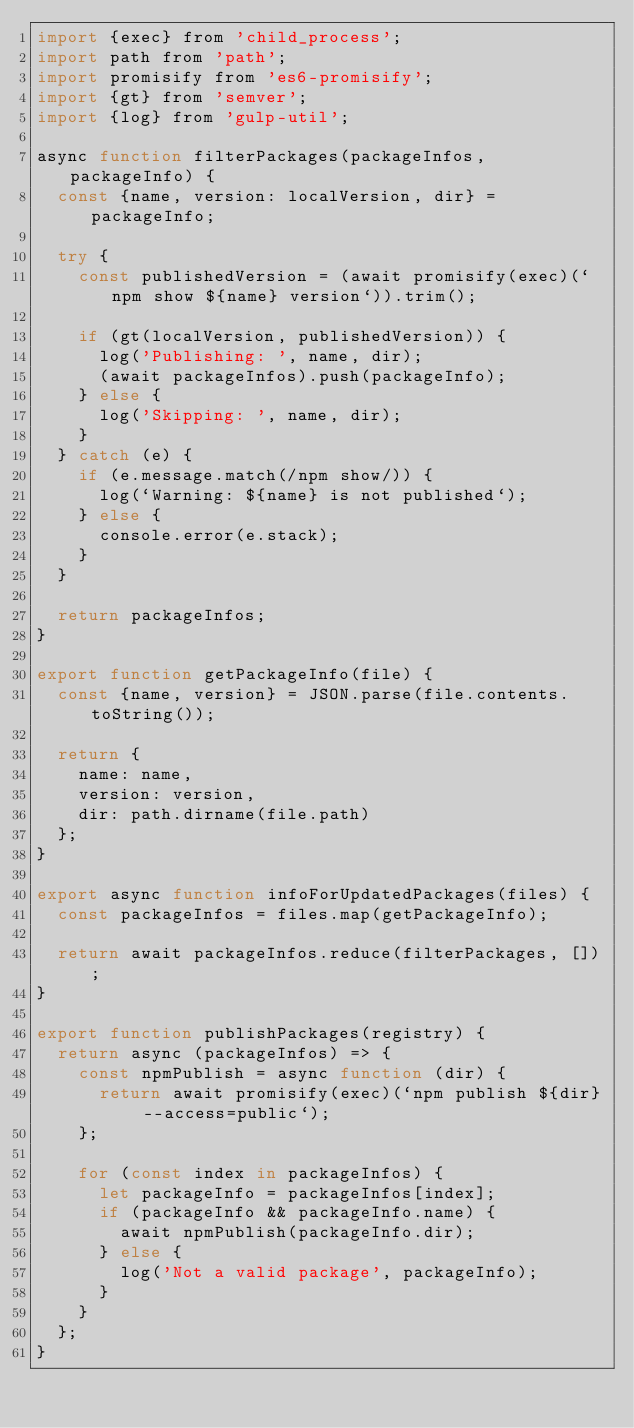Convert code to text. <code><loc_0><loc_0><loc_500><loc_500><_JavaScript_>import {exec} from 'child_process';
import path from 'path';
import promisify from 'es6-promisify';
import {gt} from 'semver';
import {log} from 'gulp-util';

async function filterPackages(packageInfos, packageInfo) {
  const {name, version: localVersion, dir} = packageInfo;

  try {
    const publishedVersion = (await promisify(exec)(`npm show ${name} version`)).trim();

    if (gt(localVersion, publishedVersion)) {
      log('Publishing: ', name, dir);
      (await packageInfos).push(packageInfo);
    } else {
      log('Skipping: ', name, dir);
    }
  } catch (e) {
    if (e.message.match(/npm show/)) {
      log(`Warning: ${name} is not published`);
    } else {
      console.error(e.stack);
    }
  }

  return packageInfos;
}

export function getPackageInfo(file) {
  const {name, version} = JSON.parse(file.contents.toString());

  return {
    name: name,
    version: version,
    dir: path.dirname(file.path)
  };
}

export async function infoForUpdatedPackages(files) {
  const packageInfos = files.map(getPackageInfo);

  return await packageInfos.reduce(filterPackages, []);
}

export function publishPackages(registry) {
  return async (packageInfos) => {
    const npmPublish = async function (dir) {
      return await promisify(exec)(`npm publish ${dir} --access=public`);
    };

    for (const index in packageInfos) {
      let packageInfo = packageInfos[index];
      if (packageInfo && packageInfo.name) {
        await npmPublish(packageInfo.dir);
      } else {
        log('Not a valid package', packageInfo);
      }
    }
  };
}
</code> 